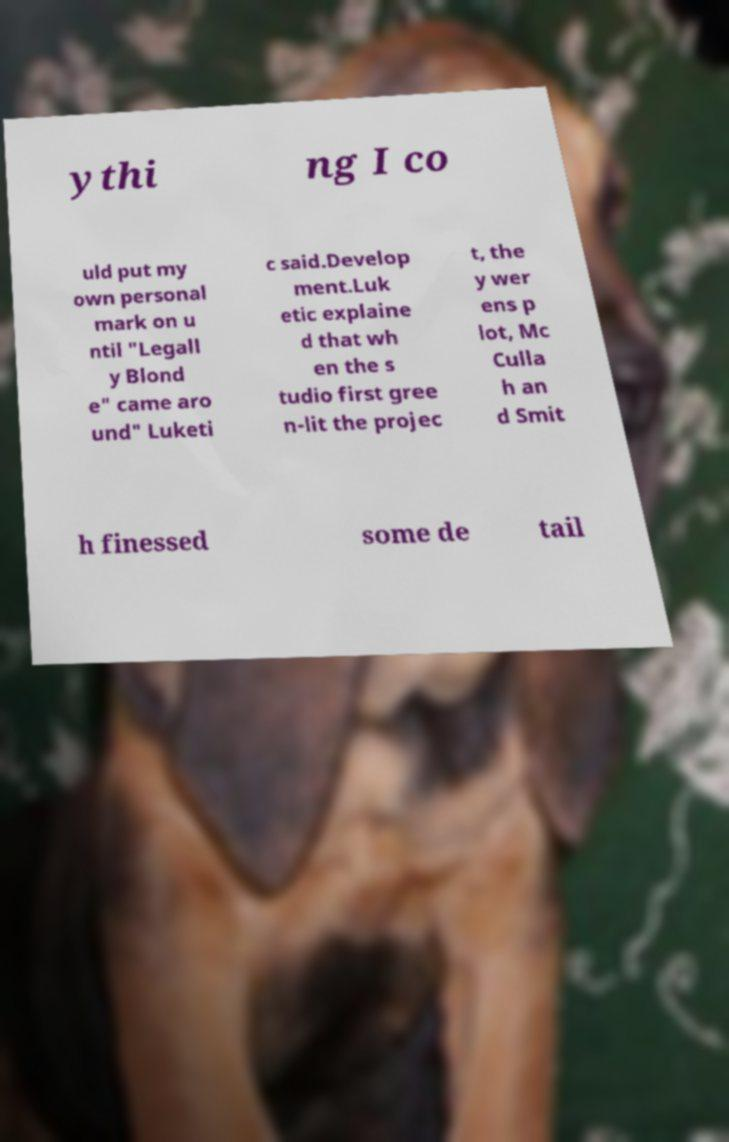Please identify and transcribe the text found in this image. ythi ng I co uld put my own personal mark on u ntil "Legall y Blond e" came aro und" Luketi c said.Develop ment.Luk etic explaine d that wh en the s tudio first gree n-lit the projec t, the y wer ens p lot, Mc Culla h an d Smit h finessed some de tail 